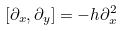Convert formula to latex. <formula><loc_0><loc_0><loc_500><loc_500>[ \partial _ { x } , \partial _ { y } ] = - h \partial _ { x } ^ { 2 }</formula> 